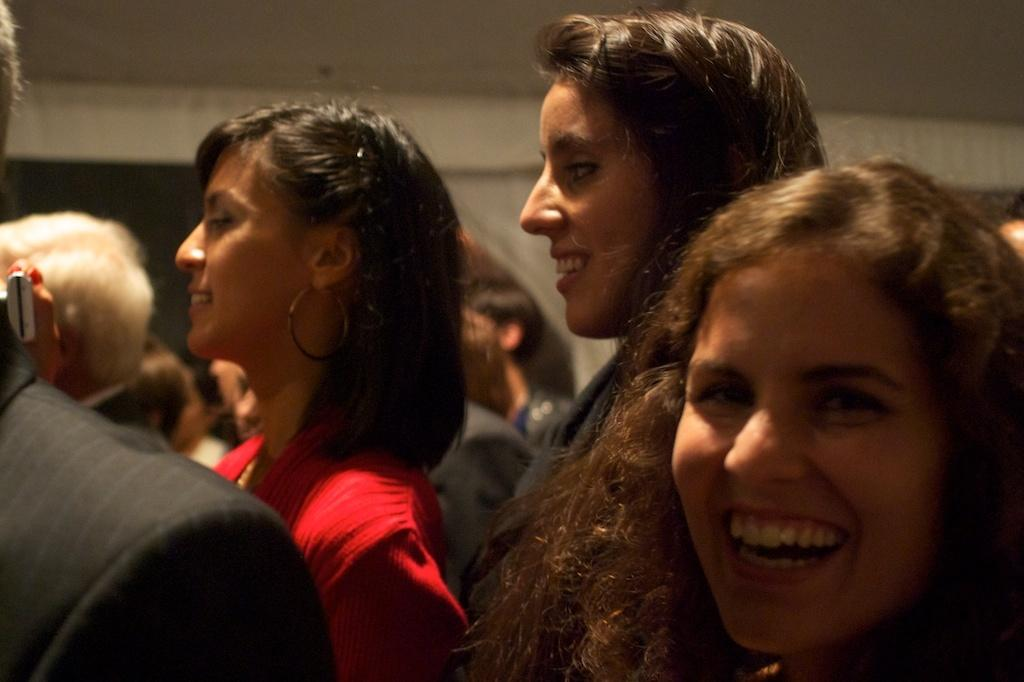How many individuals can be seen in the image? There are many people in the image. What type of chicken can be seen in the image? There are no chickens present in the image; it features many people. How many houses are visible in the image? There is no information about houses in the image; it only mentions the presence of many people. 